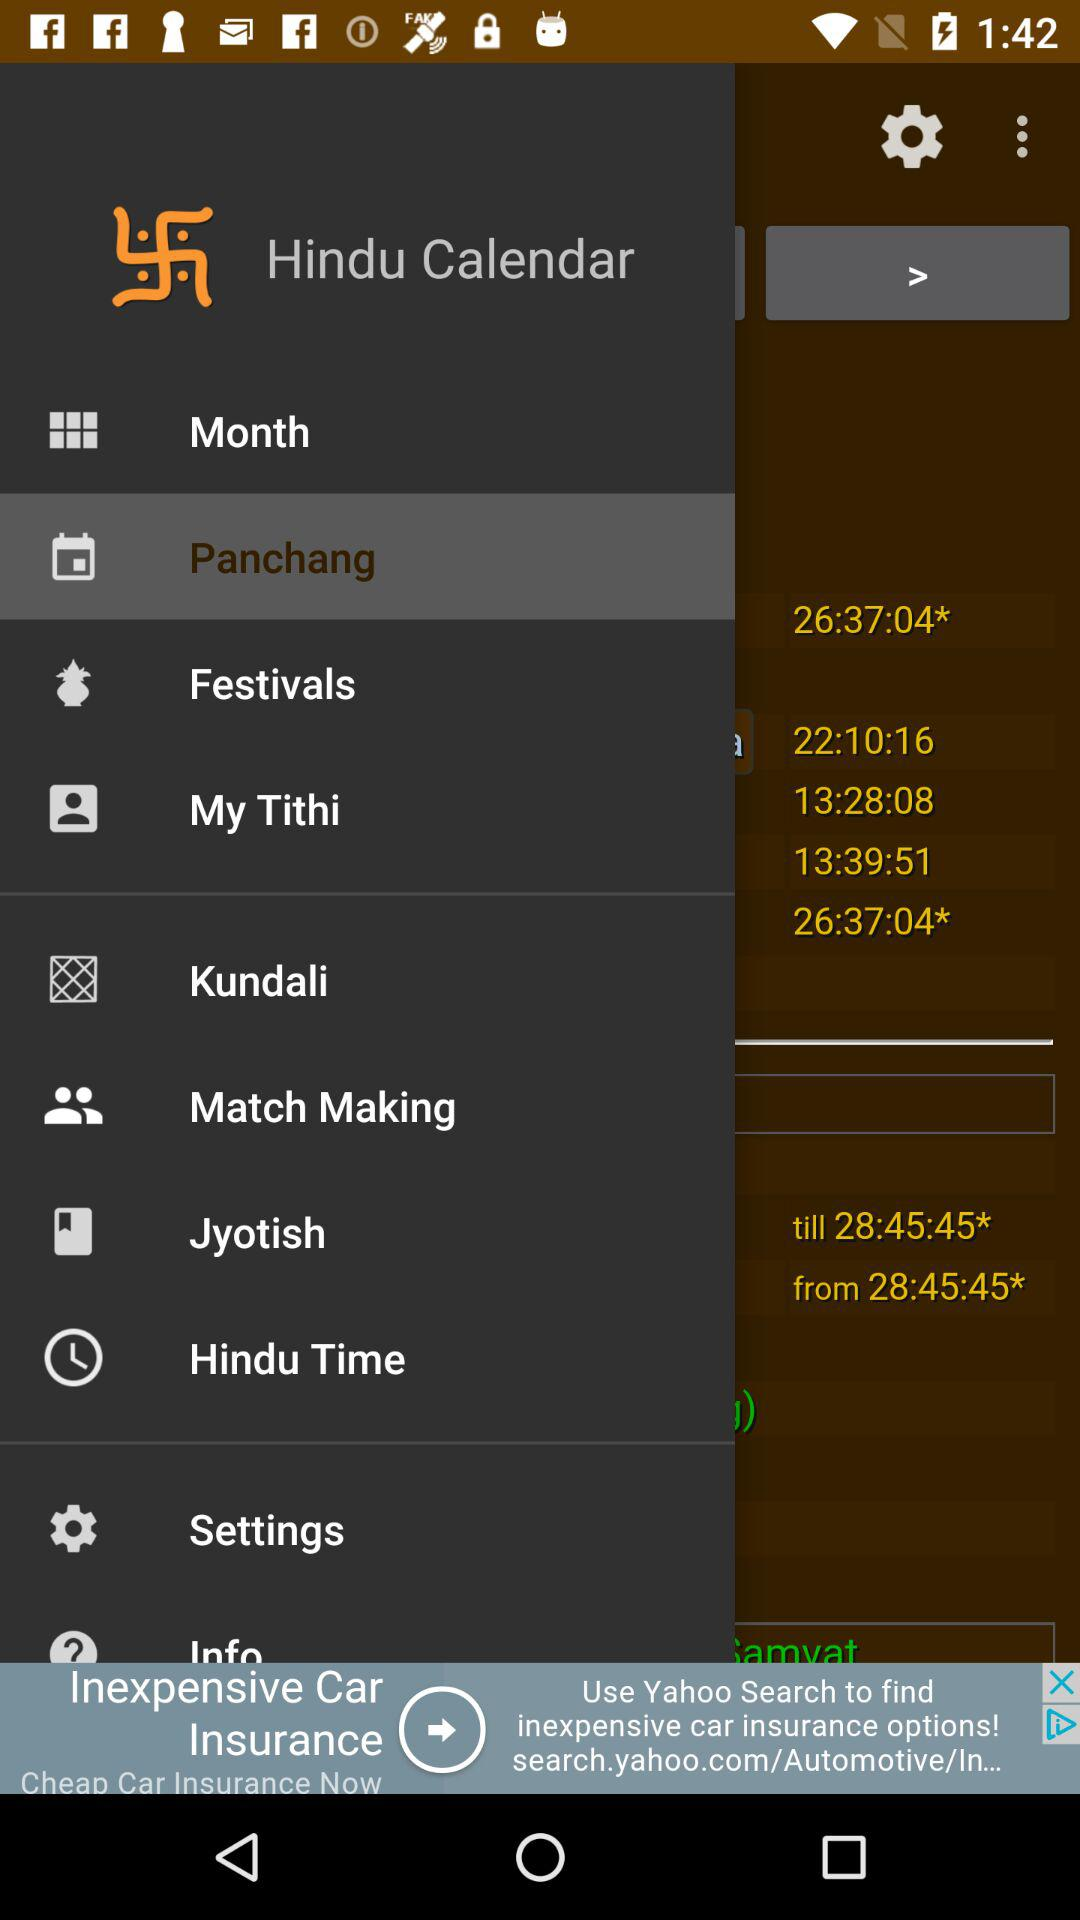What is the application name? The application name is "Hindu Calendar". 